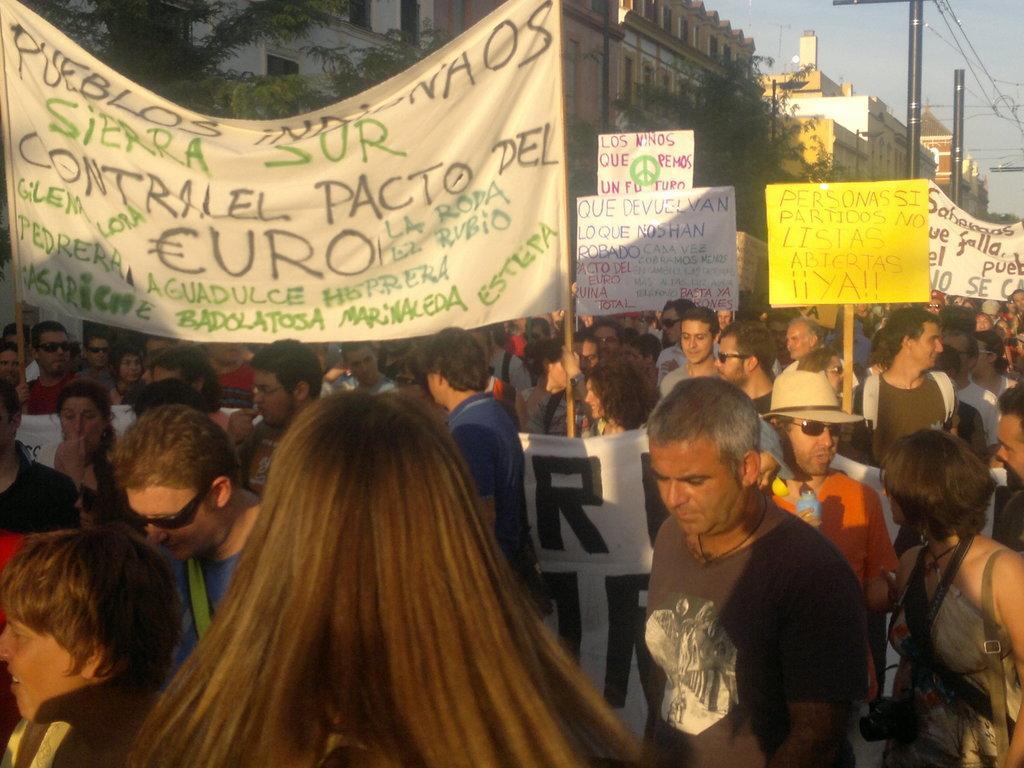How would you summarize this image in a sentence or two? In this image there are people holding the placards. In the background of the image there are trees, buildings, poles and sky. 